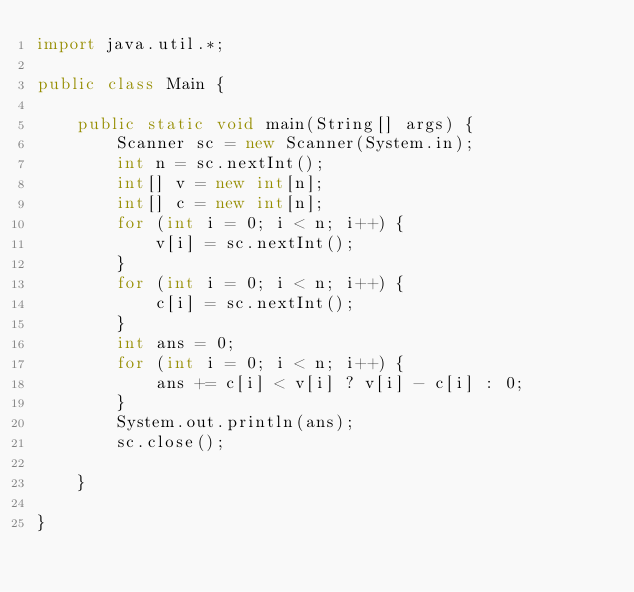<code> <loc_0><loc_0><loc_500><loc_500><_Java_>import java.util.*;

public class Main {

    public static void main(String[] args) {
        Scanner sc = new Scanner(System.in);
        int n = sc.nextInt();
        int[] v = new int[n];
        int[] c = new int[n];
        for (int i = 0; i < n; i++) {
            v[i] = sc.nextInt();
        }
        for (int i = 0; i < n; i++) {
            c[i] = sc.nextInt();
        }
        int ans = 0;
        for (int i = 0; i < n; i++) {
            ans += c[i] < v[i] ? v[i] - c[i] : 0;
        }
        System.out.println(ans);
        sc.close();

    }

}
</code> 